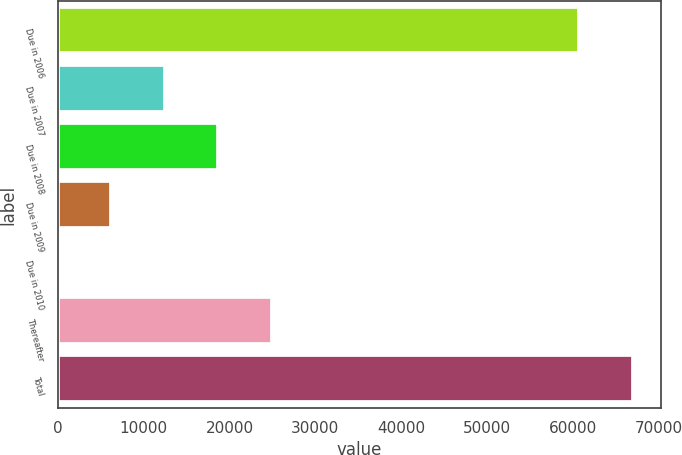Convert chart. <chart><loc_0><loc_0><loc_500><loc_500><bar_chart><fcel>Due in 2006<fcel>Due in 2007<fcel>Due in 2008<fcel>Due in 2009<fcel>Due in 2010<fcel>Thereafter<fcel>Total<nl><fcel>60733<fcel>12458.2<fcel>18686.8<fcel>6229.6<fcel>1<fcel>24915.4<fcel>66961.6<nl></chart> 